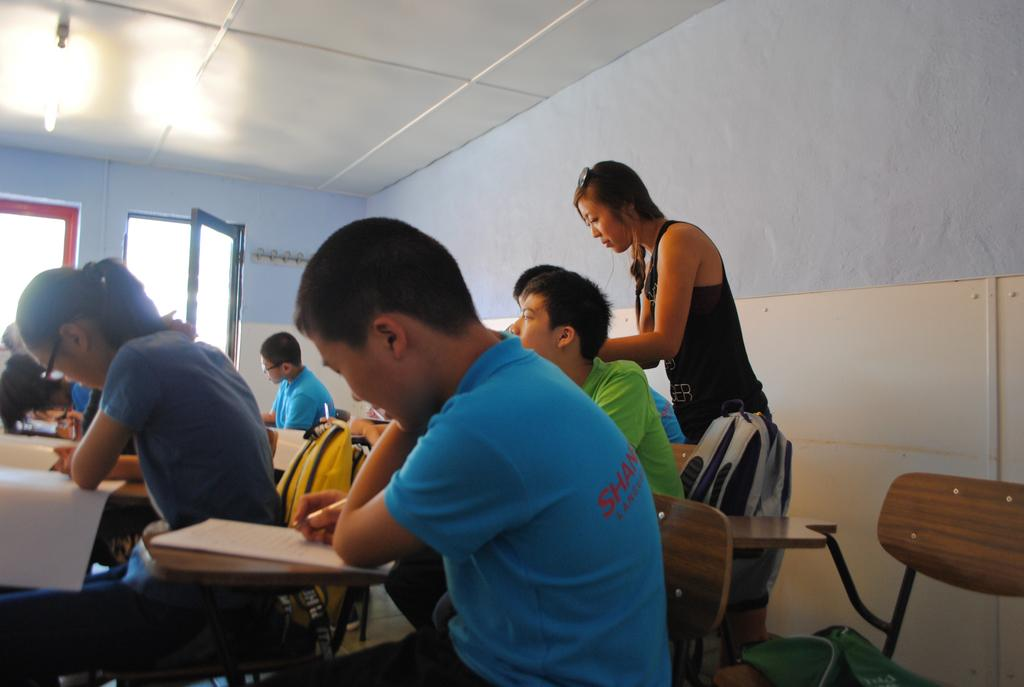What are the people in the image doing? There is a group of people sitting on chairs in the image. Where are the chairs located in the image? The chairs are in the background of the image. What can be seen behind the chairs? There is a wall and a window in the background of the image. What is the source of light in the image? There is a light at the top of the image. What is the weight of the mist in the image? There is no mist present in the image, so it is not possible to determine its weight. 